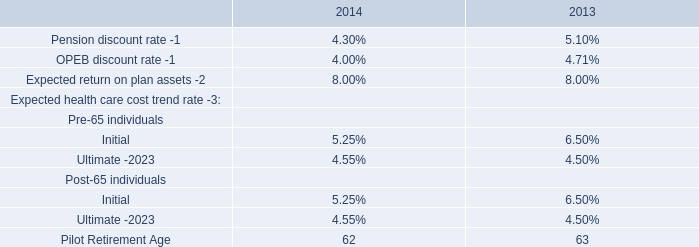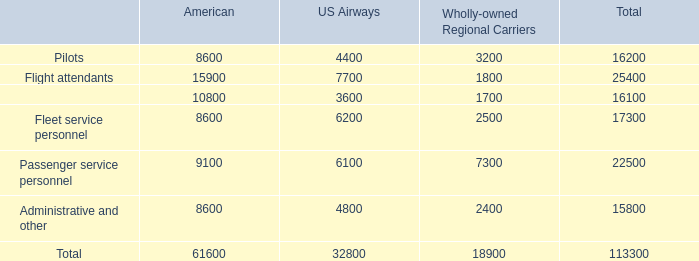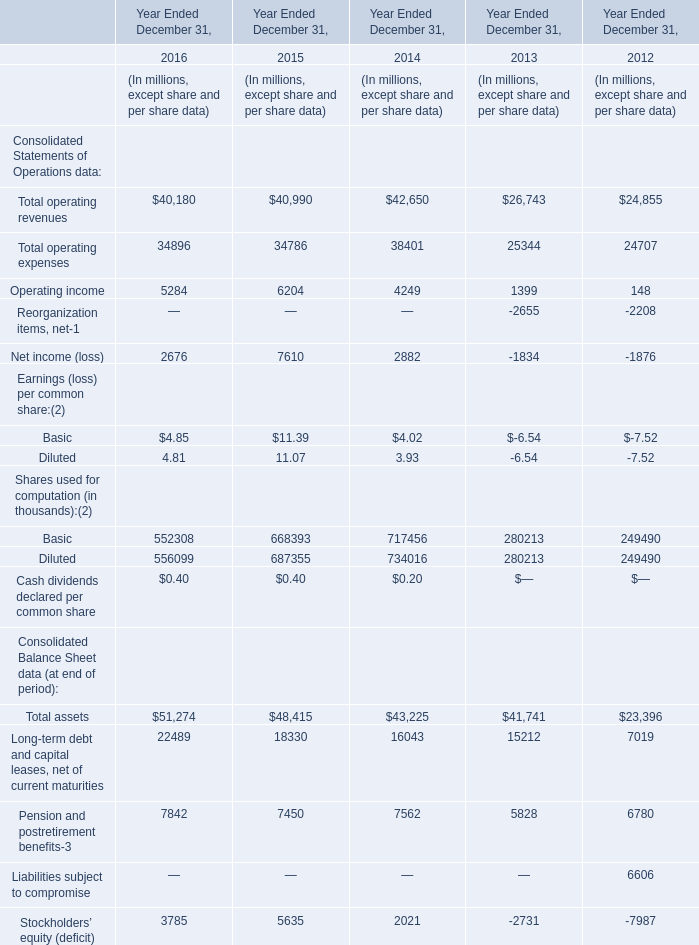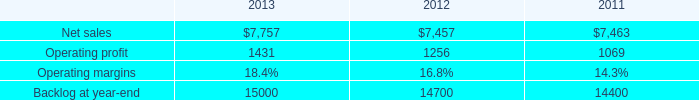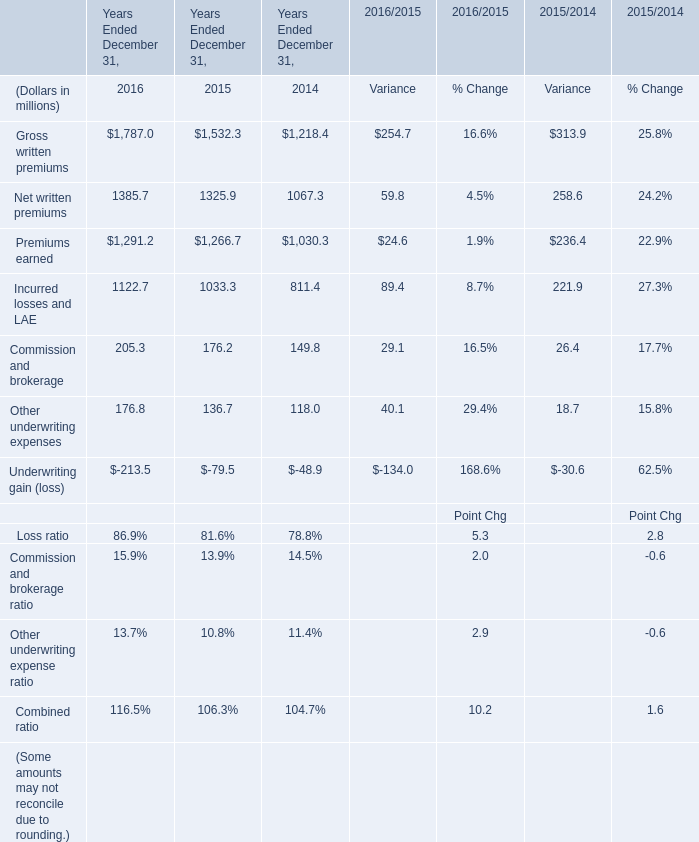The total amount of which section ranks first in 2016? 
Answer: Diluted. 